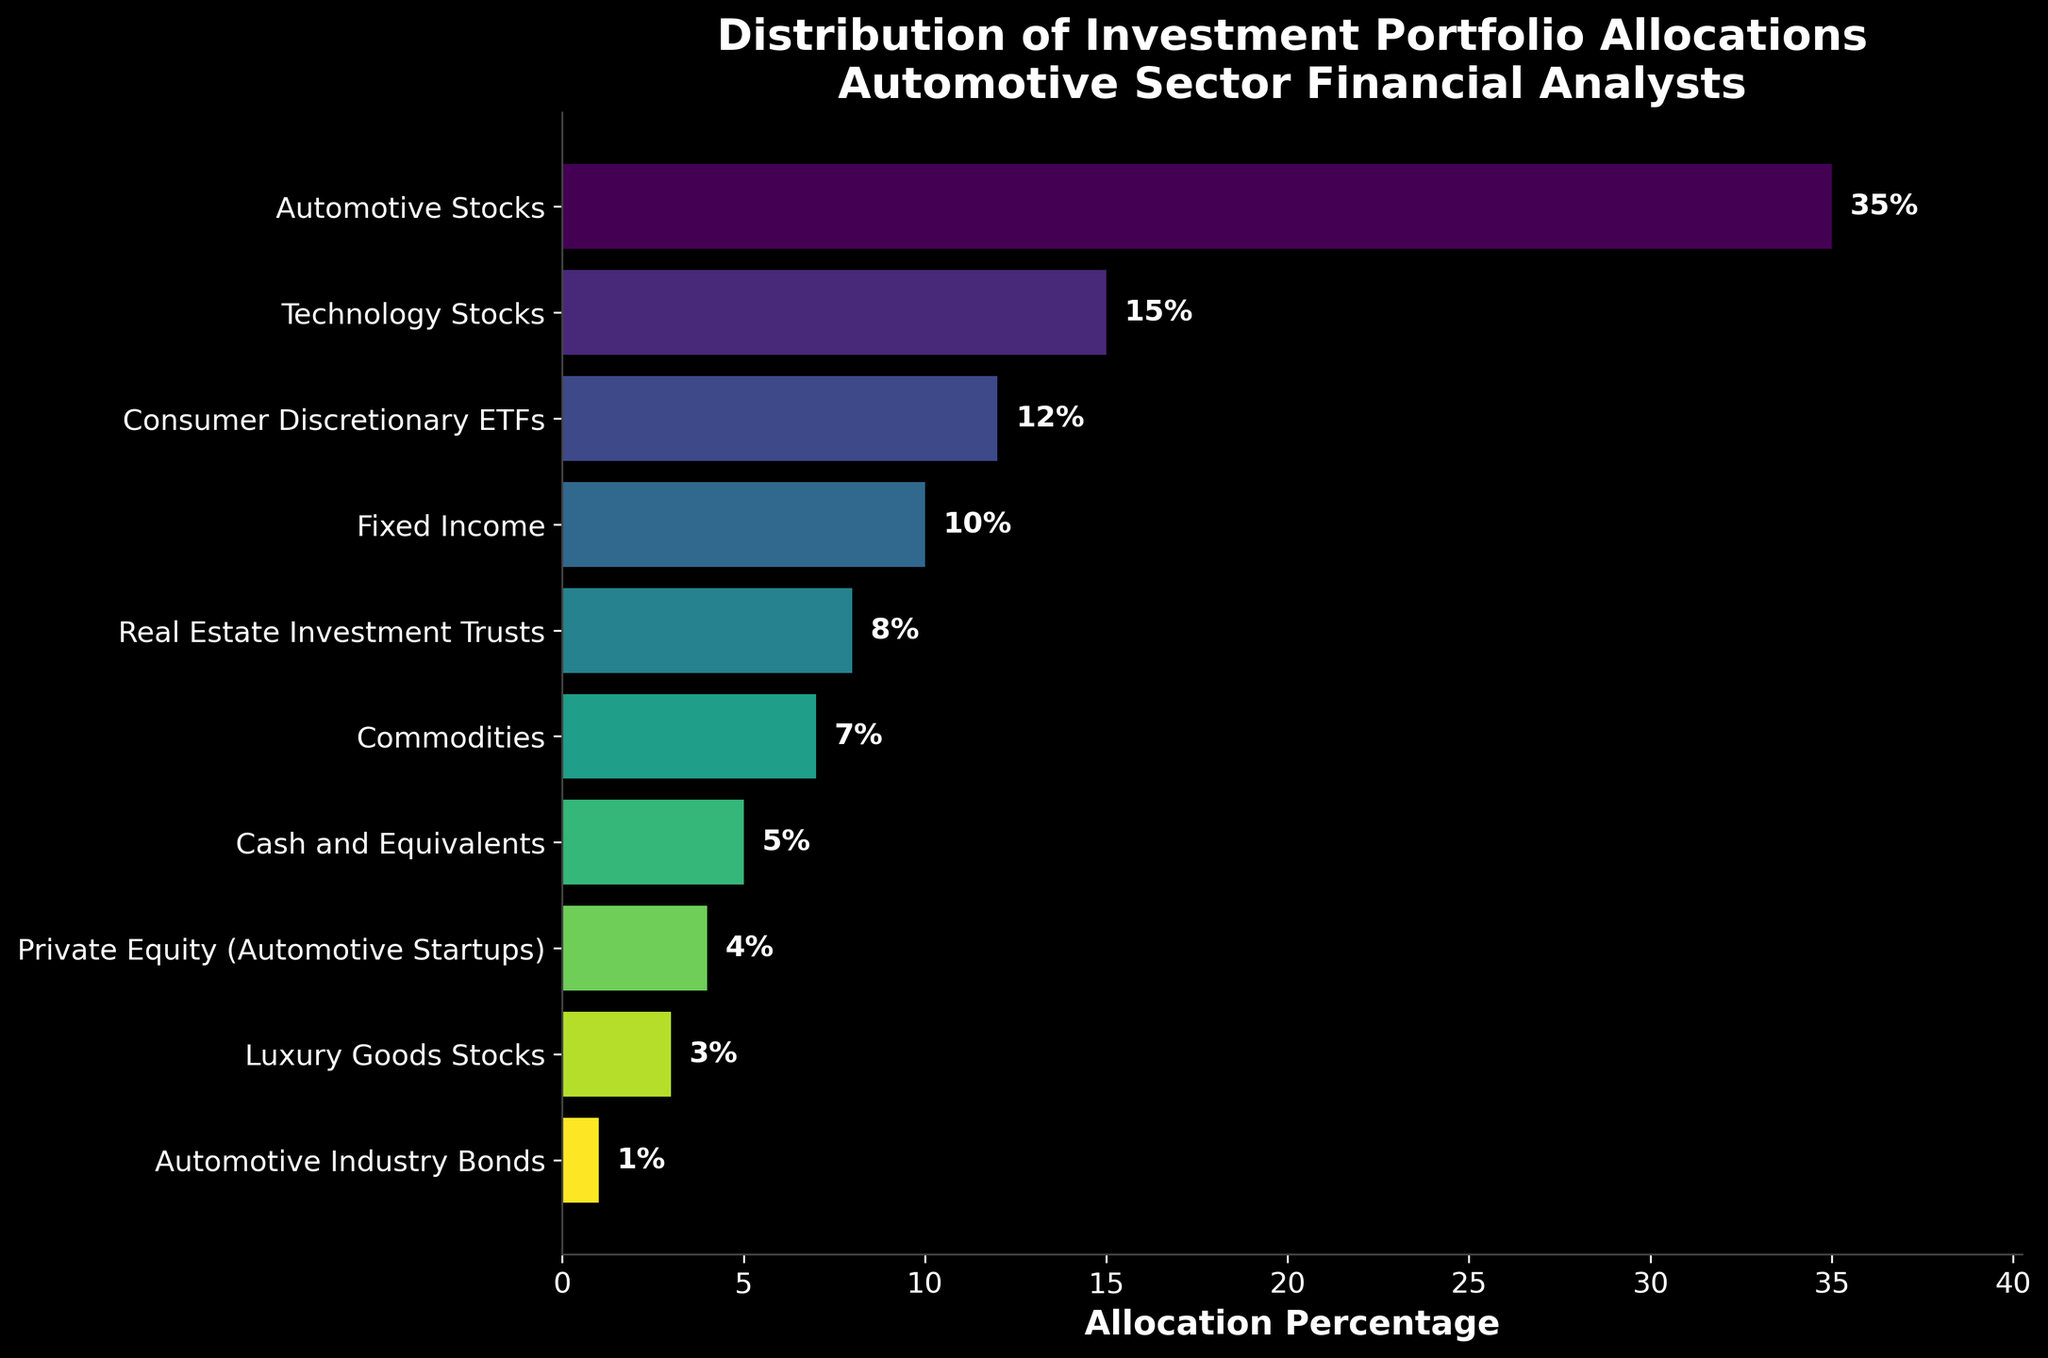What asset class has the highest allocation percentage? The bar labeled "Automotive Stocks" is the longest among all bars, indicating it has the highest allocation percentage.
Answer: Automotive Stocks What is the combined allocation percentage of Automotive Stocks and Technology Stocks? To find the combined allocation percentage, add the allocation percentages of Automotive Stocks (35%) and Technology Stocks (15%): 35 + 15 = 50
Answer: 50% Which asset class has a higher allocation percentage: Commodities or Private Equity (Automotive Startups)? Compare the lengths of the bars for Commodities (7%) and Private Equity (4%). The bar for Commodities is longer.
Answer: Commodities How much higher is the allocation for Real Estate Investment Trusts compared to Automotive Industry Bonds? To find the difference, subtract the allocation percentage of Automotive Industry Bonds (1%) from Real Estate Investment Trusts (8%): 8 - 1 = 7
Answer: 7% What is the total allocation percentage for fixed-income investments (Fixed Income and Automotive Industry Bonds combined)? Add the allocation percentages for Fixed Income (10%) and Automotive Industry Bonds (1%): 10 + 1 = 11
Answer: 11% Which asset class has the lowest allocation percentage? The shortest bar represents Automotive Industry Bonds, indicating it has the lowest allocation percentage.
Answer: Automotive Industry Bonds What is the average allocation percentage across all asset classes? Sum all the allocation percentages (35 + 15 + 12 + 10 + 8 + 7 + 5 + 4 + 3 + 1 = 100) and divide by the number of asset classes (10): 100 / 10 = 10
Answer: 10% Is the allocation percentage for Cash and Equivalents greater than or equal to that for Commodities? Compare the bars for Cash and Equivalents (5%) and Commodities (7%). The bar for Cash and Equivalents is shorter.
Answer: No Which asset classes have allocation percentages less than 10%? Identify all bars shorter than the 10% mark: Real Estate Investment Trusts (8%), Commodities (7%), Cash and Equivalents (5%), Private Equity (4%), Luxury Goods Stocks (3%), and Automotive Industry Bonds (1%).
Answer: Real Estate Investment Trusts, Commodities, Cash and Equivalents, Private Equity (Automotive Startups), Luxury Goods Stocks, Automotive Industry Bonds 